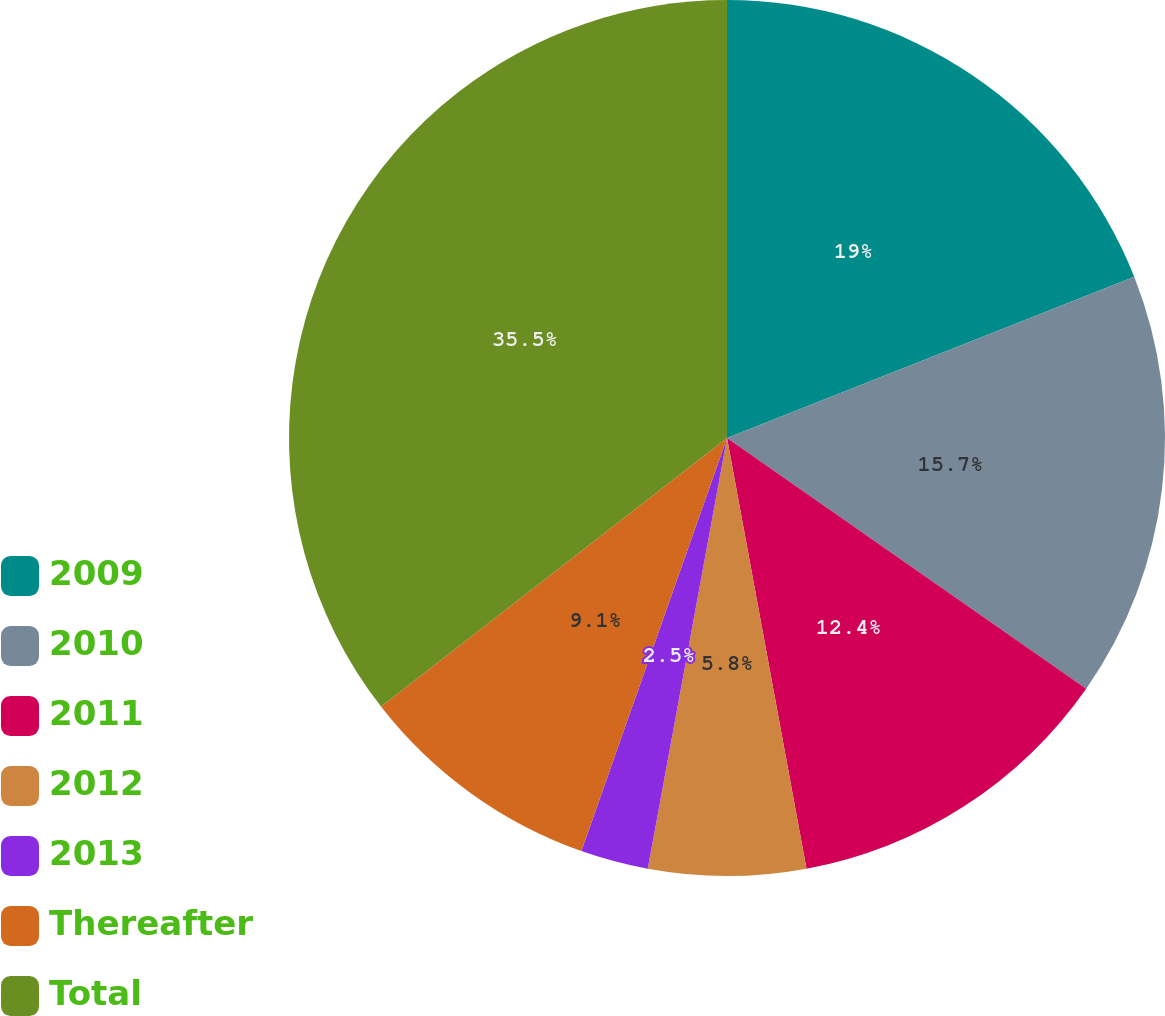Convert chart. <chart><loc_0><loc_0><loc_500><loc_500><pie_chart><fcel>2009<fcel>2010<fcel>2011<fcel>2012<fcel>2013<fcel>Thereafter<fcel>Total<nl><fcel>19.0%<fcel>15.7%<fcel>12.4%<fcel>5.8%<fcel>2.5%<fcel>9.1%<fcel>35.51%<nl></chart> 